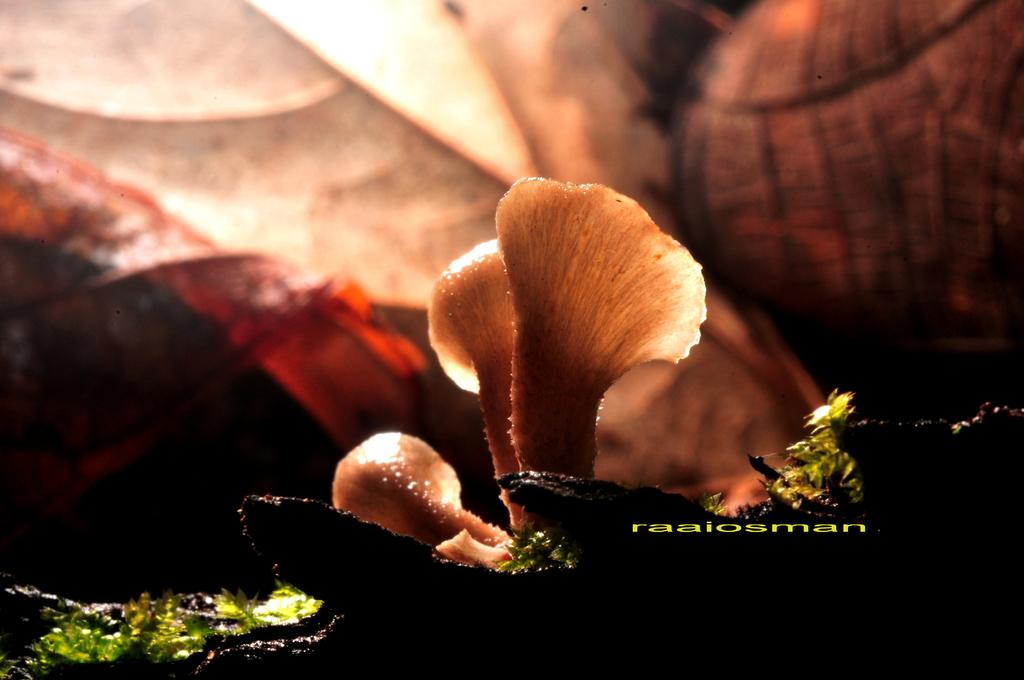What type of plants can be seen in the picture? There are flowers and leaves in the picture. What is written or depicted at the bottom of the picture? There is text at the bottom of the picture. How would you describe the background of the picture? The background of the picture is blurry. What is the interest rate on the flowers in the picture? There is no mention of interest rates in the picture, as it features flowers and leaves. 